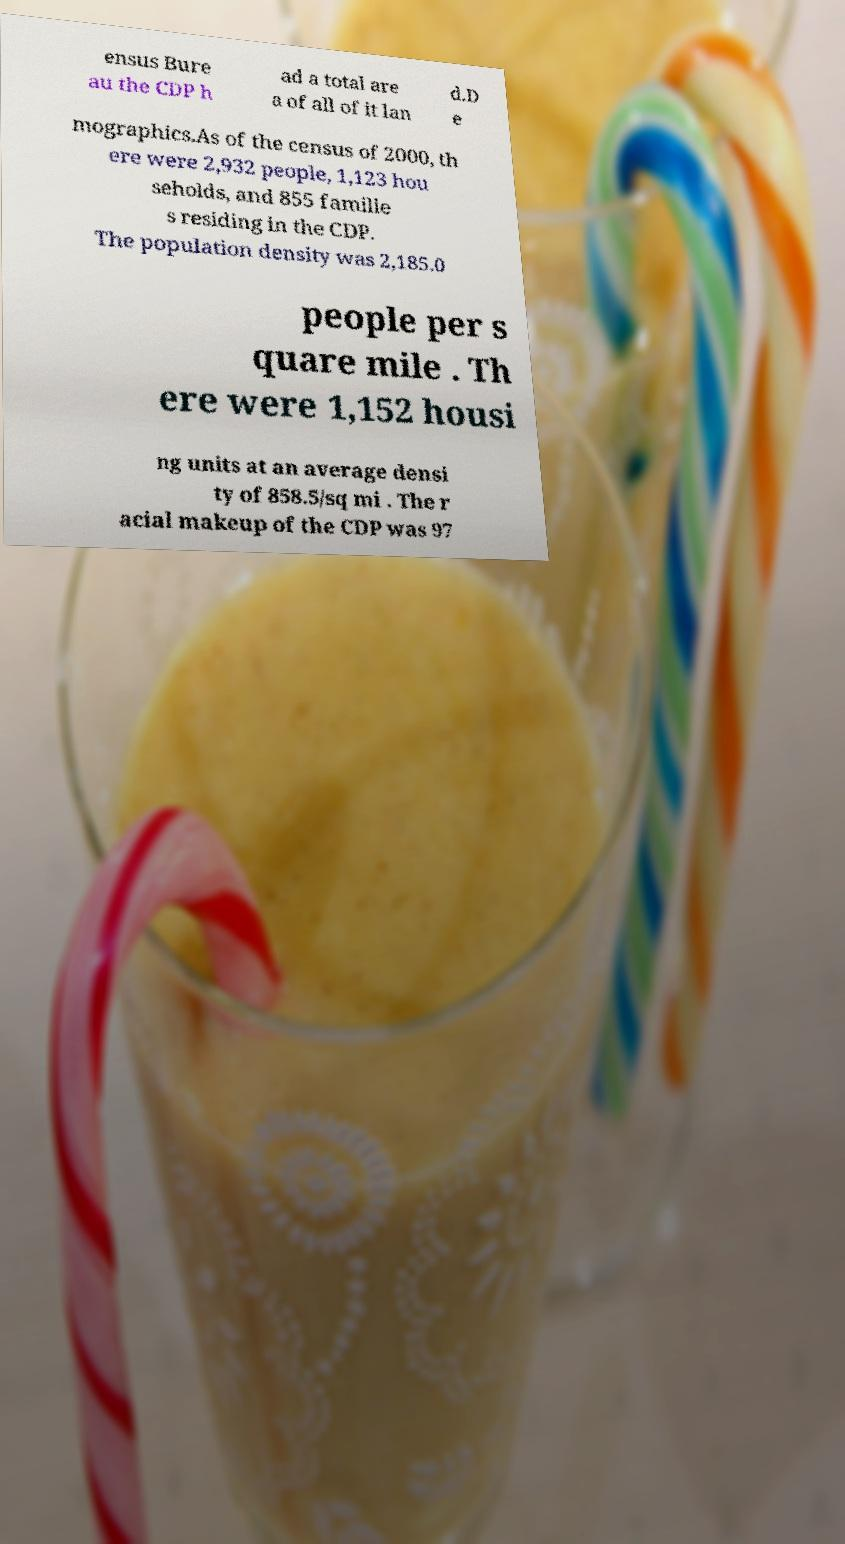Can you accurately transcribe the text from the provided image for me? ensus Bure au the CDP h ad a total are a of all of it lan d.D e mographics.As of the census of 2000, th ere were 2,932 people, 1,123 hou seholds, and 855 familie s residing in the CDP. The population density was 2,185.0 people per s quare mile . Th ere were 1,152 housi ng units at an average densi ty of 858.5/sq mi . The r acial makeup of the CDP was 97 